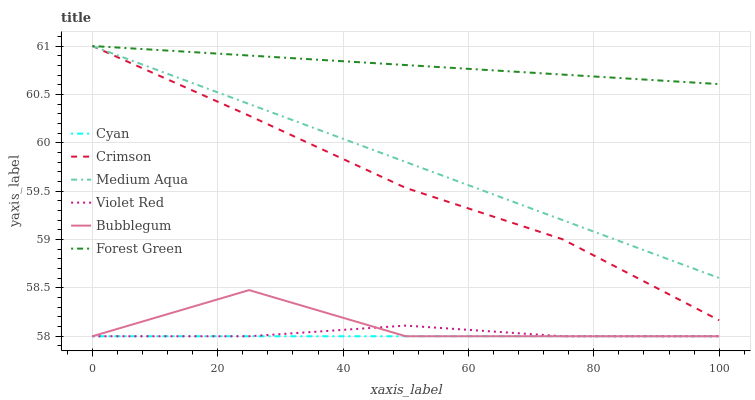Does Cyan have the minimum area under the curve?
Answer yes or no. Yes. Does Forest Green have the maximum area under the curve?
Answer yes or no. Yes. Does Bubblegum have the minimum area under the curve?
Answer yes or no. No. Does Bubblegum have the maximum area under the curve?
Answer yes or no. No. Is Forest Green the smoothest?
Answer yes or no. Yes. Is Bubblegum the roughest?
Answer yes or no. Yes. Is Bubblegum the smoothest?
Answer yes or no. No. Is Forest Green the roughest?
Answer yes or no. No. Does Violet Red have the lowest value?
Answer yes or no. Yes. Does Forest Green have the lowest value?
Answer yes or no. No. Does Crimson have the highest value?
Answer yes or no. Yes. Does Bubblegum have the highest value?
Answer yes or no. No. Is Cyan less than Forest Green?
Answer yes or no. Yes. Is Crimson greater than Cyan?
Answer yes or no. Yes. Does Forest Green intersect Medium Aqua?
Answer yes or no. Yes. Is Forest Green less than Medium Aqua?
Answer yes or no. No. Is Forest Green greater than Medium Aqua?
Answer yes or no. No. Does Cyan intersect Forest Green?
Answer yes or no. No. 